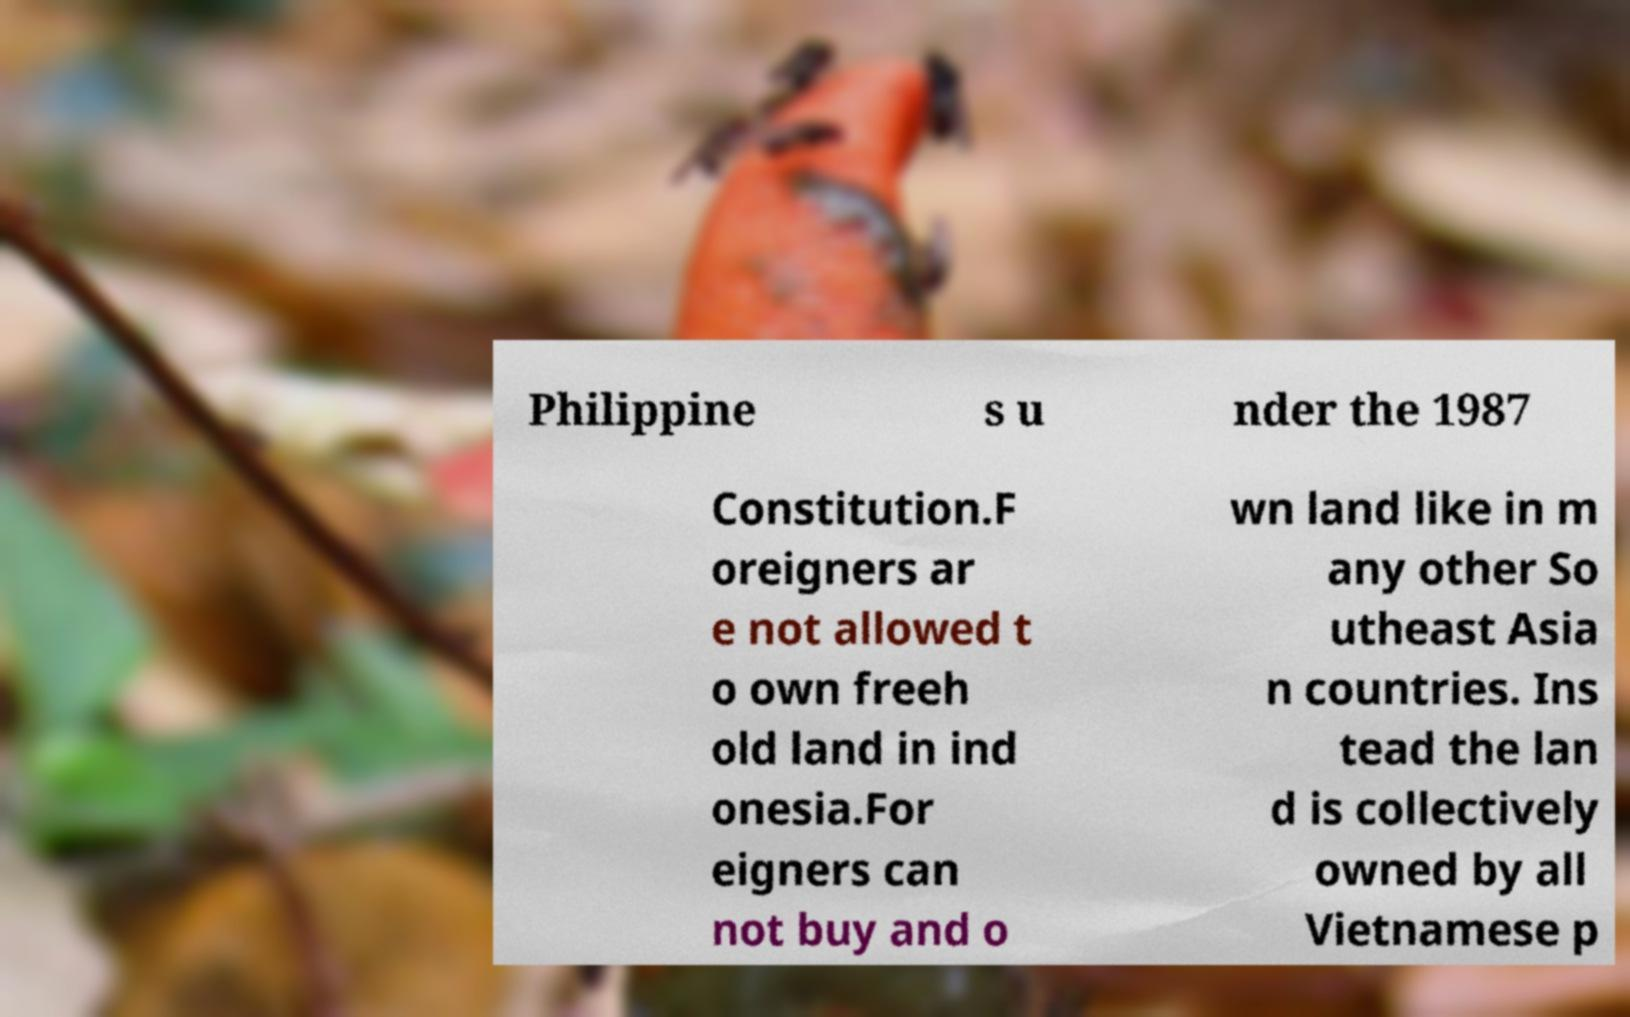What messages or text are displayed in this image? I need them in a readable, typed format. Philippine s u nder the 1987 Constitution.F oreigners ar e not allowed t o own freeh old land in ind onesia.For eigners can not buy and o wn land like in m any other So utheast Asia n countries. Ins tead the lan d is collectively owned by all Vietnamese p 